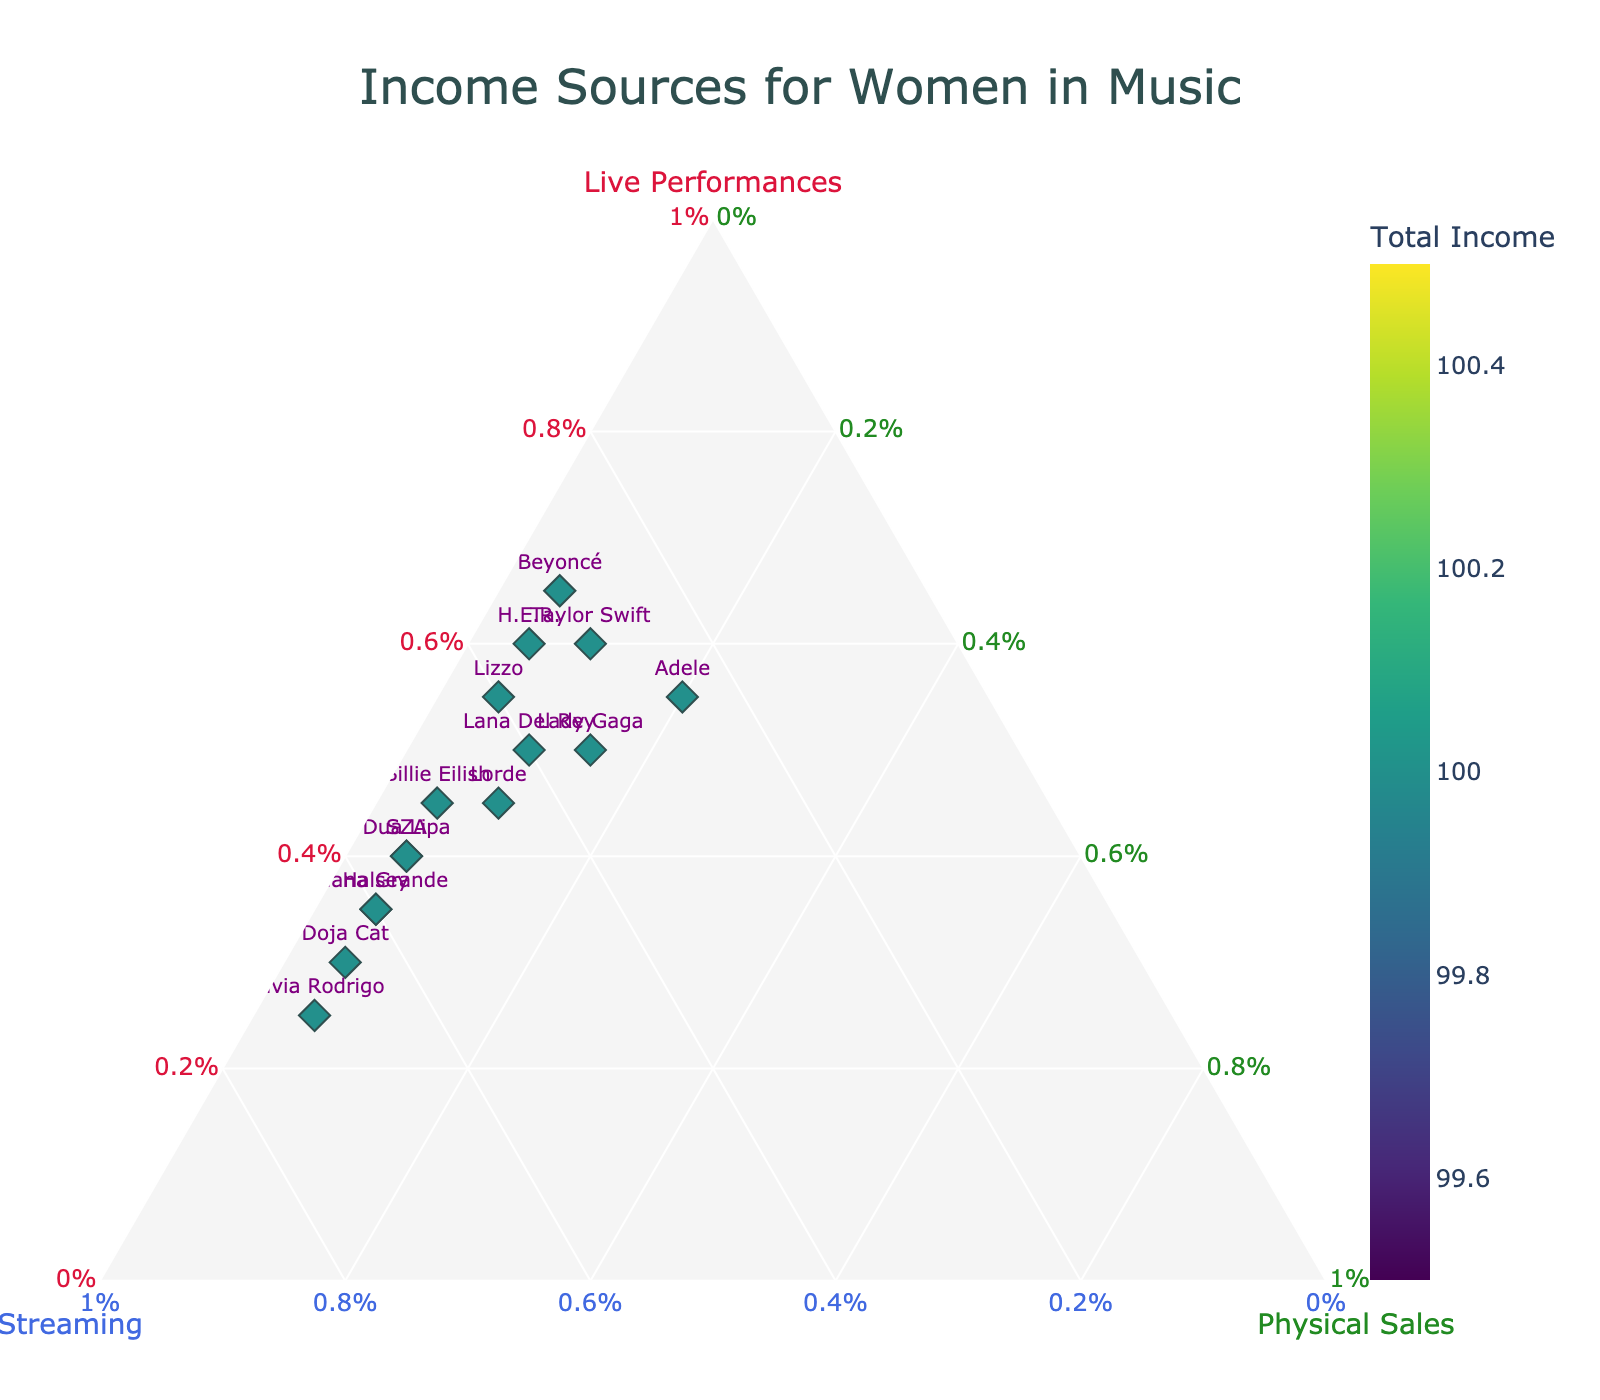What is the title of the plot? The title is usually displayed at the top center of the figure. Here, it reads "Income Sources for Women in Music".
Answer: Income Sources for Women in Music How many musicians are shown in the plot? By looking at the scattered points marked with names, we can count the total number of musicians displayed.
Answer: 15 Which artist has the highest proportion of income from live performances? To identify this, look for the point that is closest to the 'Live Performances' vertex of the ternary plot. Taylor Swift and Beyoncé are the nearest, both having the highest percentage.
Answer: Taylor Swift and Beyoncé Which artist has the highest total income? The total income is represented by the color intensity (colorbar) on the plot. Olivia Rodrigo has the darkest hue indicating the highest total income.
Answer: Olivia Rodrigo Compare the income sources of Billie Eilish and Dua Lipa. Which one has a higher proportion of income from streaming? To compare, find the points marked as Billie Eilish and Dua Lipa. The one that is closer to the 'Streaming' vertex has a higher proportion. Dua Lipa is closer to the 'Streaming' vertex.
Answer: Dua Lipa What percentage of Ariana Grande's income is from streaming? Locate the point marked as Ariana Grande and use the hover template information. It shows the proportion of income from different sources.
Answer: 60% How do the income sources of Taylor Swift and Lorde compare in terms of physical sales? Check the proximity of their points to the 'Physical Sales' vertex. Taylor Swift has 10% income from physical sales, while Lorde has the same percentage.
Answer: Equal Identify the artist with the least proportion of income from live performances. Search for the point farthest from the 'Live Performances' vertex. Olivia Rodrigo is furthest with 25%.
Answer: Olivia Rodrigo Which artists have a similar income distribution from streaming? (Choose at least two). Look for pairs of points in similar positions along the 'Streaming' axis. SZA and Dua Lipa both share around 55%.
Answer: SZA and Dua Lipa What is the percentage difference between H.E.R. and Lana Del Rey's income from physical sales? Check the exact percentages for both H.E.R. and Lana Del Rey from hover information. H.E.R. has 5%, while Lana Del Rey has 10%. The difference is 5%.
Answer: 5% 